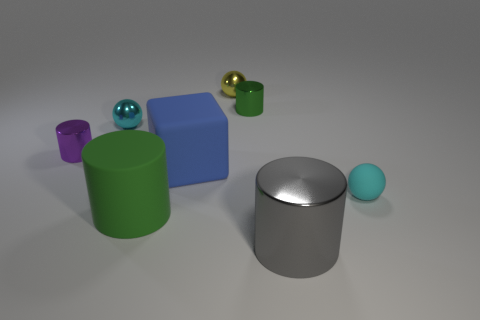What is the shape of the large thing that is the same material as the small yellow object?
Make the answer very short. Cylinder. Does the green thing that is to the left of the tiny green cylinder have the same material as the cube?
Keep it short and to the point. Yes. How many other things are made of the same material as the purple cylinder?
Provide a short and direct response. 4. What number of things are either green cylinders left of the big matte block or tiny cyan spheres that are in front of the big cube?
Provide a short and direct response. 2. Do the tiny cyan thing behind the large blue matte block and the object on the right side of the gray cylinder have the same shape?
Make the answer very short. Yes. There is a green thing that is the same size as the yellow shiny thing; what shape is it?
Keep it short and to the point. Cylinder. How many shiny objects are either small blue objects or cyan spheres?
Give a very brief answer. 1. Is the material of the big blue block to the left of the big shiny cylinder the same as the sphere in front of the purple shiny object?
Make the answer very short. Yes. What is the color of the small sphere that is the same material as the large blue cube?
Give a very brief answer. Cyan. Are there more big green matte objects that are to the right of the large gray metal cylinder than big metallic cylinders in front of the yellow metal sphere?
Keep it short and to the point. No. 